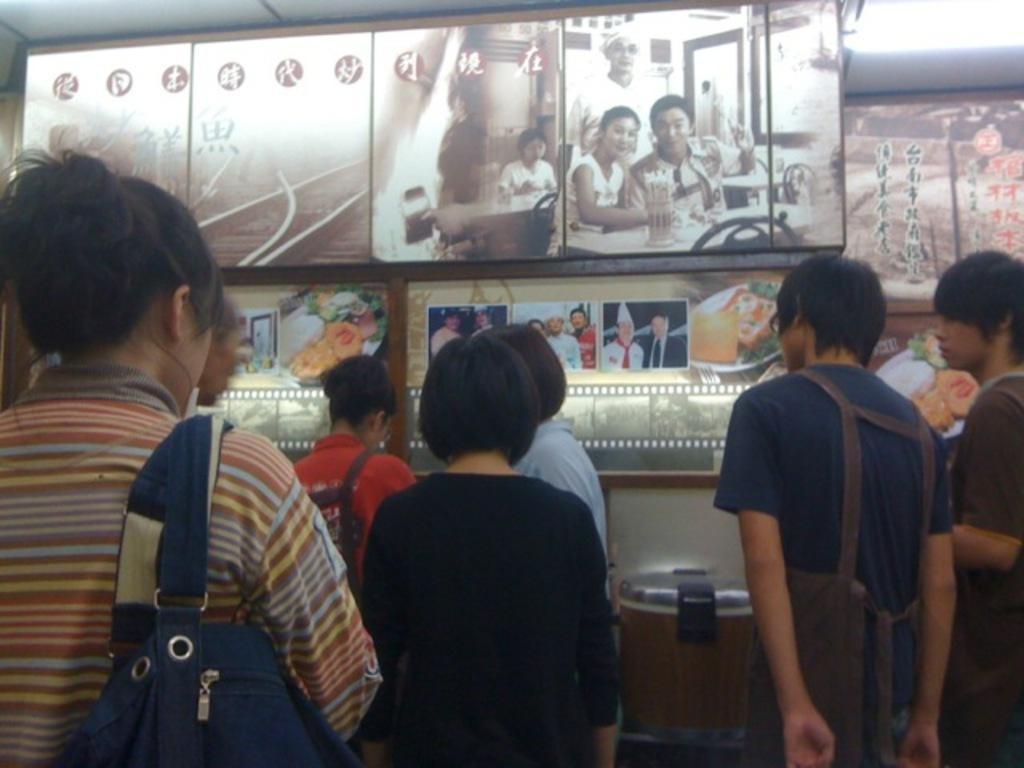How many persons are in the center of the image? There are multiple persons standing in the center of the image. What is the surface on which the persons are standing? There is a floor visible in the image. What can be seen in the background of the image? There are advertisements and photographs of persons in the background of the image, as well as a wall. Can you describe the wilderness area visible in the image? There is no wilderness area visible in the image; it features multiple persons standing in the center, a floor, and a background with advertisements, photographs, and a wall. What type of yam is being used as a prop by one of the persons in the image? There is no yam present in the image; it only features multiple persons, a floor, and a background with advertisements, photographs, and a wall. 